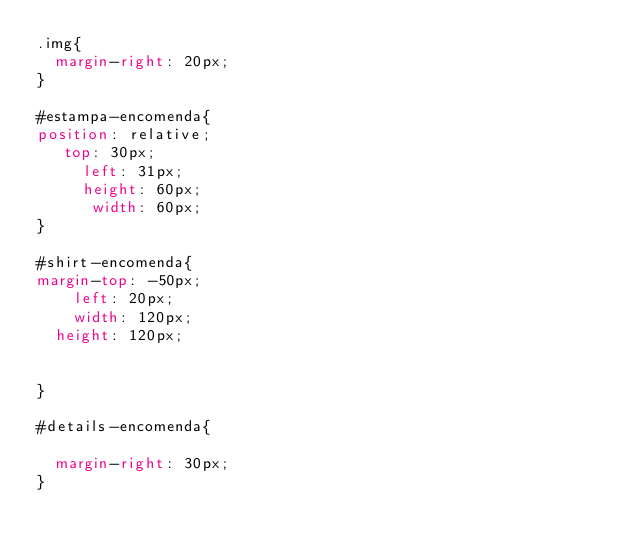<code> <loc_0><loc_0><loc_500><loc_500><_CSS_>.img{
	margin-right: 20px;
}

#estampa-encomenda{
position: relative;
	 top: 30px;
     left: 31px;
     height: 60px;
      width: 60px;
}

#shirt-encomenda{
margin-top: -50px;
    left: 20px;
    width: 120px;
	height: 120px;


}

#details-encomenda{
	
	margin-right: 30px;
}</code> 